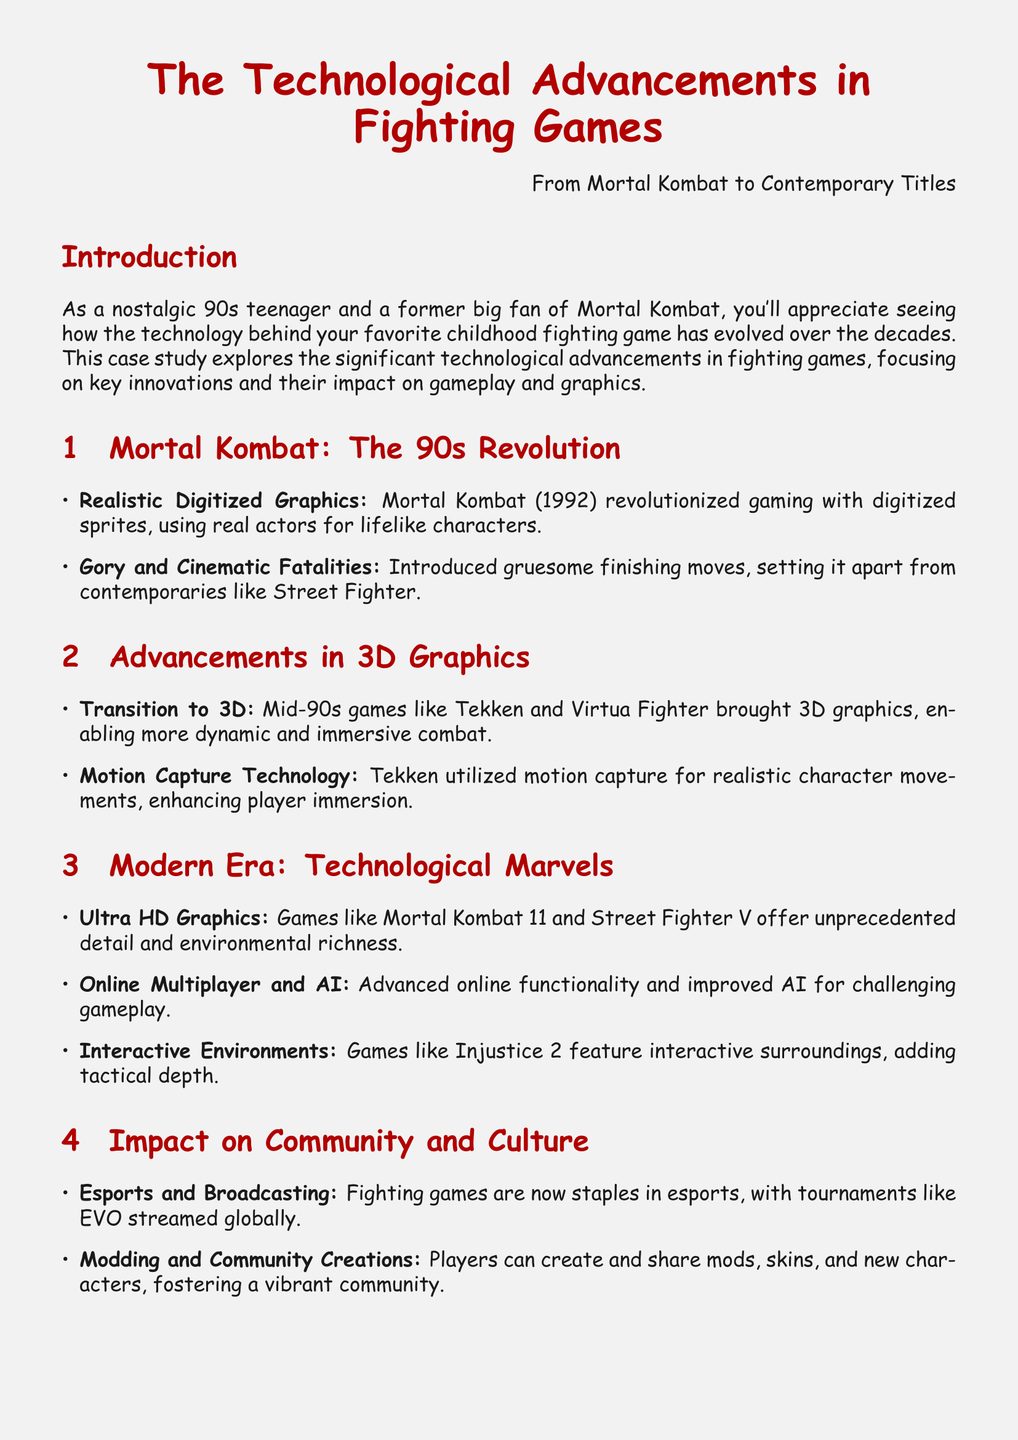what year was Mortal Kombat released? The document states that Mortal Kombat was released in 1992.
Answer: 1992 what technology did Tekken utilize for character movements? The document mentions that Tekken used motion capture technology for realistic character movements.
Answer: motion capture technology what graphics quality do Mortal Kombat 11 and Street Fighter V offer? The document specifies that these games offer Ultra HD graphics.
Answer: Ultra HD graphics what genre has become a staple in esports? The document indicates that fighting games are now staples in esports.
Answer: fighting games what feature does Injustice 2 introduce to gameplay? The document states that Injustice 2 features interactive environments, adding tactical depth.
Answer: interactive environments how did Mortal Kombat set itself apart from contemporaries? The document notes that Mortal Kombat introduced gory and cinematic fatalities, setting it apart from others like Street Fighter.
Answer: gory and cinematic fatalities what has fostered a vibrant community around fighting games? The document highlights that modding and community creations have fostered a vibrant community.
Answer: modding and community creations what was the primary graphical advancement in mid-90s fighting games? The document discusses that the transition to 3D was a primary graphical advancement in mid-90s fighting games.
Answer: transition to 3D which event is mentioned as significant in broadcasting fighting games? The document refers to tournaments like EVO as staples in esports that are streamed globally.
Answer: EVO 